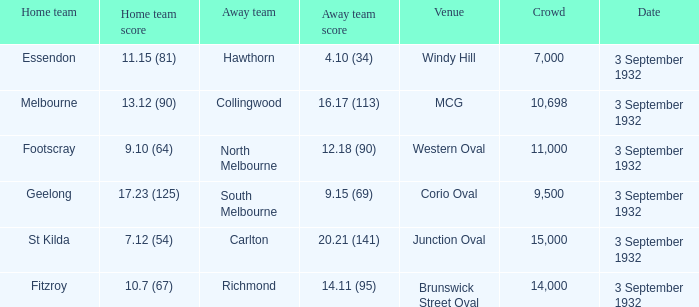What date is listed for the team that has an Away team score of 20.21 (141)? 3 September 1932. 